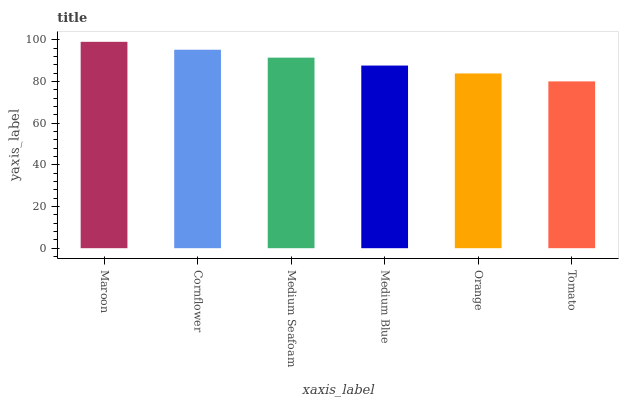Is Cornflower the minimum?
Answer yes or no. No. Is Cornflower the maximum?
Answer yes or no. No. Is Maroon greater than Cornflower?
Answer yes or no. Yes. Is Cornflower less than Maroon?
Answer yes or no. Yes. Is Cornflower greater than Maroon?
Answer yes or no. No. Is Maroon less than Cornflower?
Answer yes or no. No. Is Medium Seafoam the high median?
Answer yes or no. Yes. Is Medium Blue the low median?
Answer yes or no. Yes. Is Orange the high median?
Answer yes or no. No. Is Tomato the low median?
Answer yes or no. No. 